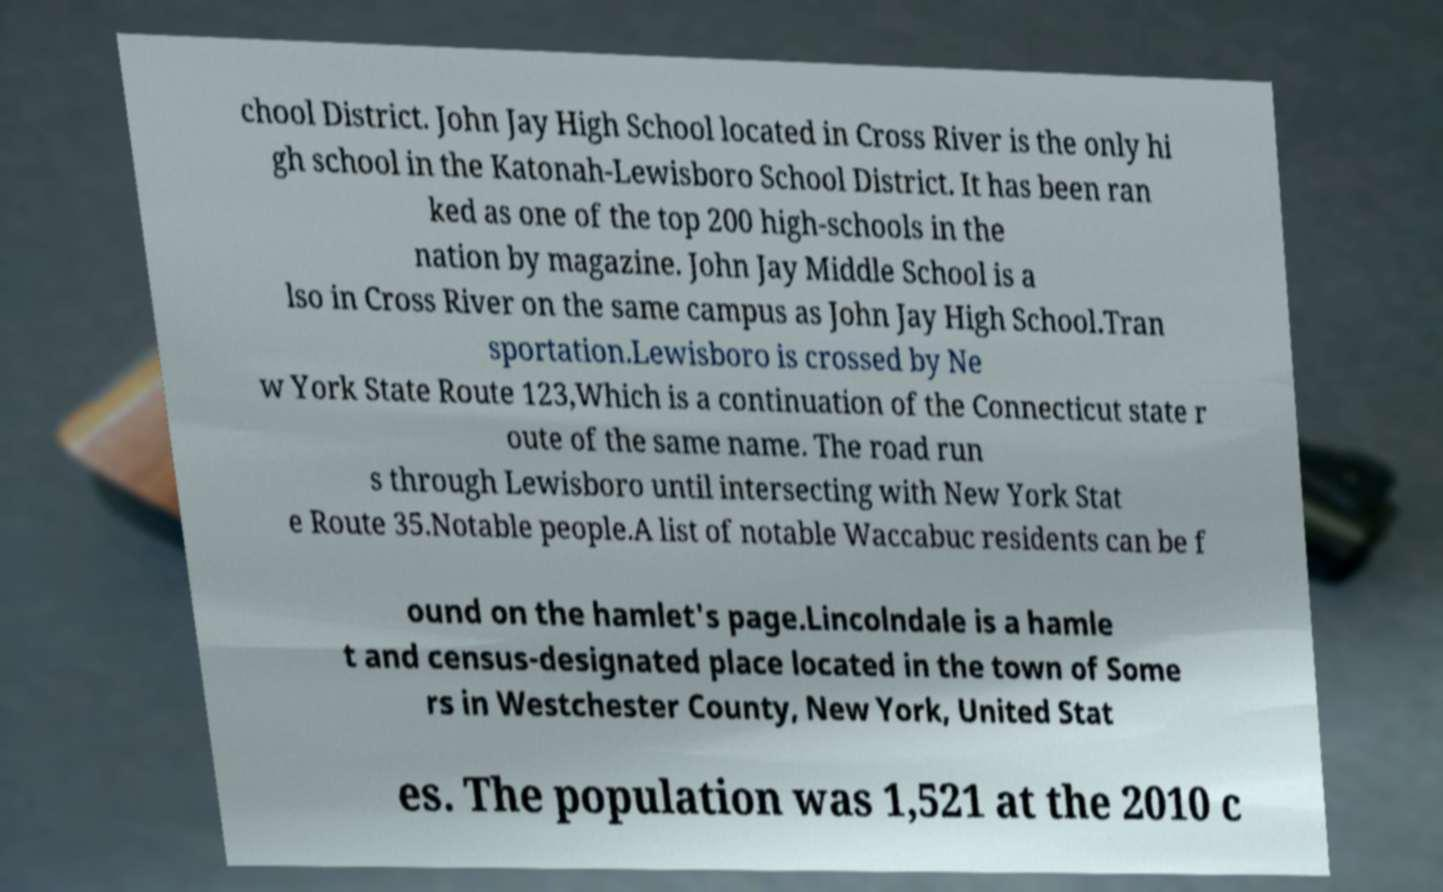Please read and relay the text visible in this image. What does it say? chool District. John Jay High School located in Cross River is the only hi gh school in the Katonah-Lewisboro School District. It has been ran ked as one of the top 200 high-schools in the nation by magazine. John Jay Middle School is a lso in Cross River on the same campus as John Jay High School.Tran sportation.Lewisboro is crossed by Ne w York State Route 123,Which is a continuation of the Connecticut state r oute of the same name. The road run s through Lewisboro until intersecting with New York Stat e Route 35.Notable people.A list of notable Waccabuc residents can be f ound on the hamlet's page.Lincolndale is a hamle t and census-designated place located in the town of Some rs in Westchester County, New York, United Stat es. The population was 1,521 at the 2010 c 